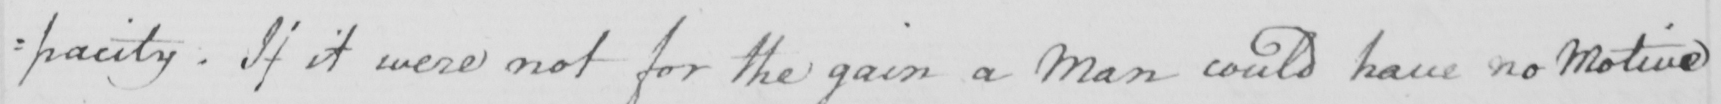What does this handwritten line say? : pacity . If it were not for the gain a Man could have no Motive 